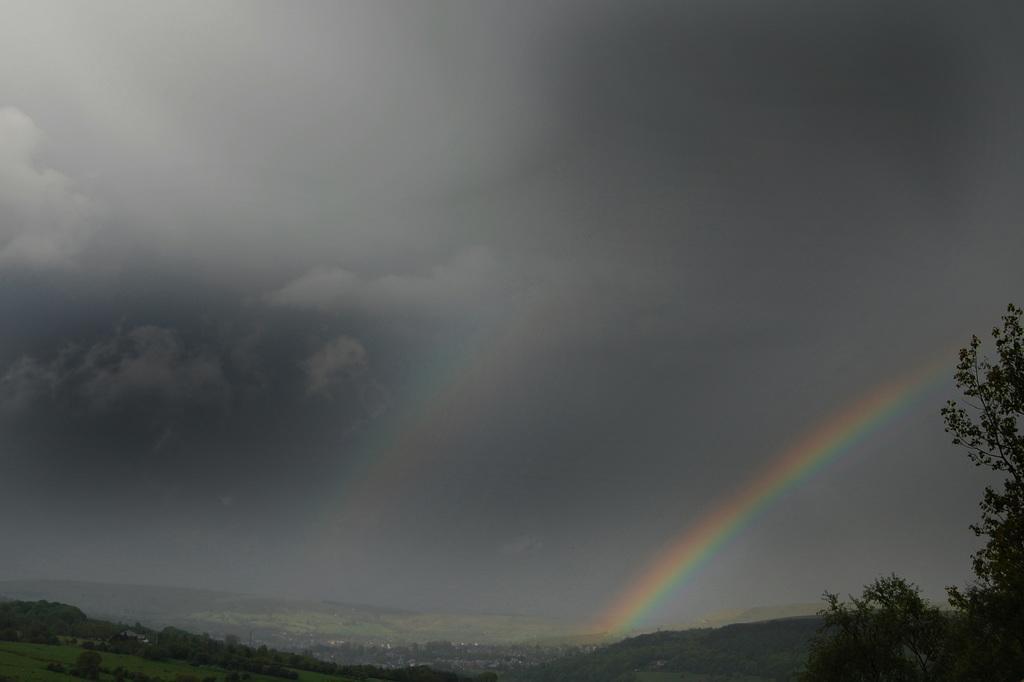Please provide a concise description of this image. This picture shows few trees and black cloudy sky and we see couple of rainbows. 